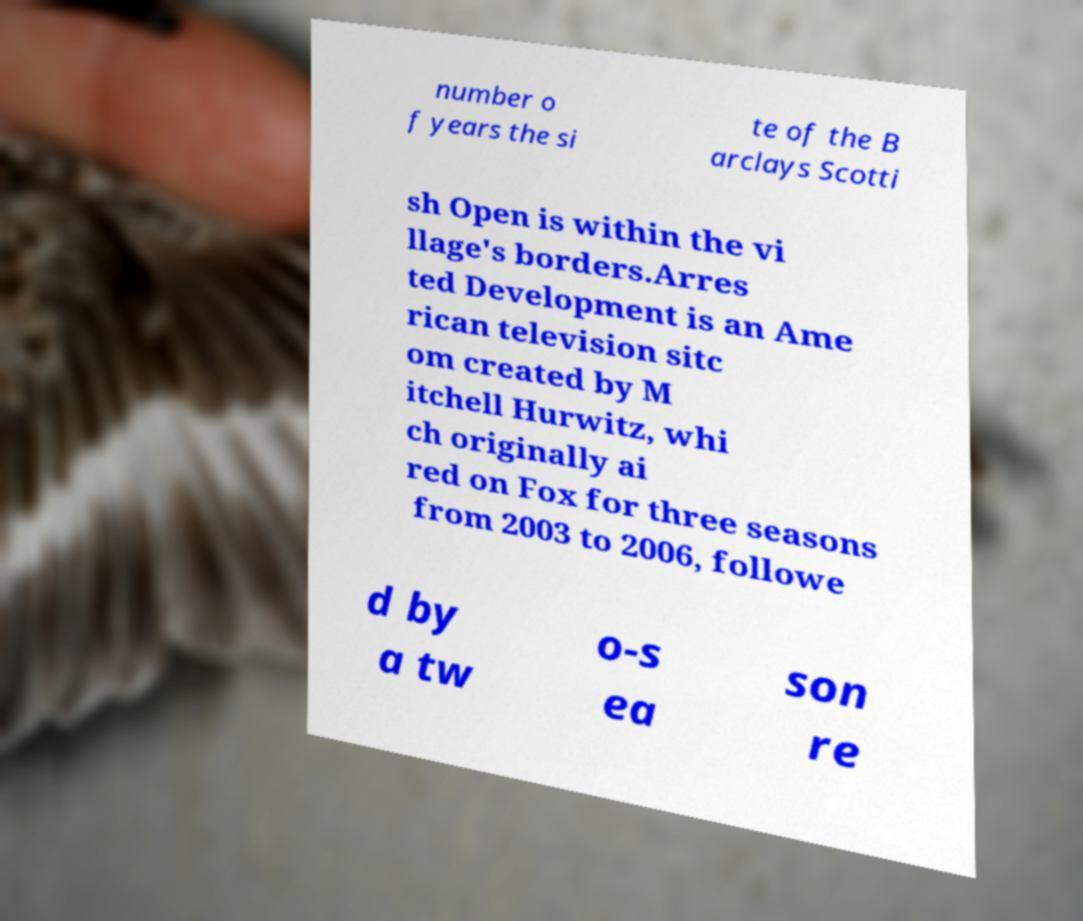Could you extract and type out the text from this image? number o f years the si te of the B arclays Scotti sh Open is within the vi llage's borders.Arres ted Development is an Ame rican television sitc om created by M itchell Hurwitz, whi ch originally ai red on Fox for three seasons from 2003 to 2006, followe d by a tw o-s ea son re 